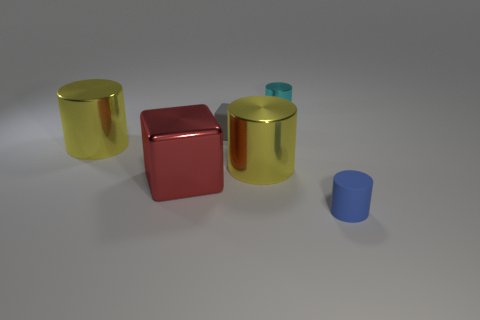Add 3 matte blocks. How many objects exist? 9 Subtract all tiny cyan metal cylinders. How many cylinders are left? 3 Subtract 1 red cubes. How many objects are left? 5 Subtract all cylinders. How many objects are left? 2 Subtract 1 cubes. How many cubes are left? 1 Subtract all brown cylinders. Subtract all green cubes. How many cylinders are left? 4 Subtract all cyan balls. How many red cubes are left? 1 Subtract all blue objects. Subtract all red metal blocks. How many objects are left? 4 Add 5 small cyan things. How many small cyan things are left? 6 Add 4 large red shiny blocks. How many large red shiny blocks exist? 5 